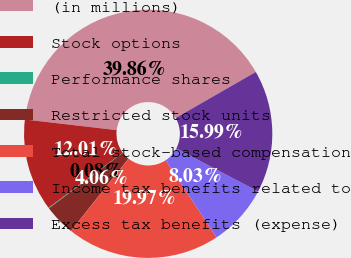<chart> <loc_0><loc_0><loc_500><loc_500><pie_chart><fcel>(in millions)<fcel>Stock options<fcel>Performance shares<fcel>Restricted stock units<fcel>Total stock-based compensation<fcel>Income tax benefits related to<fcel>Excess tax benefits (expense)<nl><fcel>39.86%<fcel>12.01%<fcel>0.08%<fcel>4.06%<fcel>19.97%<fcel>8.03%<fcel>15.99%<nl></chart> 